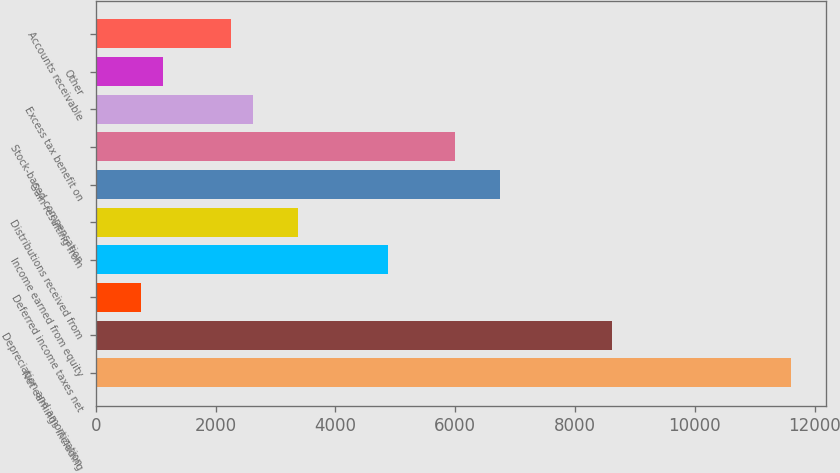<chart> <loc_0><loc_0><loc_500><loc_500><bar_chart><fcel>Net earnings including<fcel>Depreciation and amortization<fcel>Deferred income taxes net<fcel>Income earned from equity<fcel>Distributions received from<fcel>Gain resulting from<fcel>Stock-based compensation<fcel>Excess tax benefit on<fcel>Other<fcel>Accounts receivable<nl><fcel>11603.5<fcel>8611.36<fcel>756.94<fcel>4871.16<fcel>3375.08<fcel>6741.26<fcel>5993.22<fcel>2627.04<fcel>1130.96<fcel>2253.02<nl></chart> 